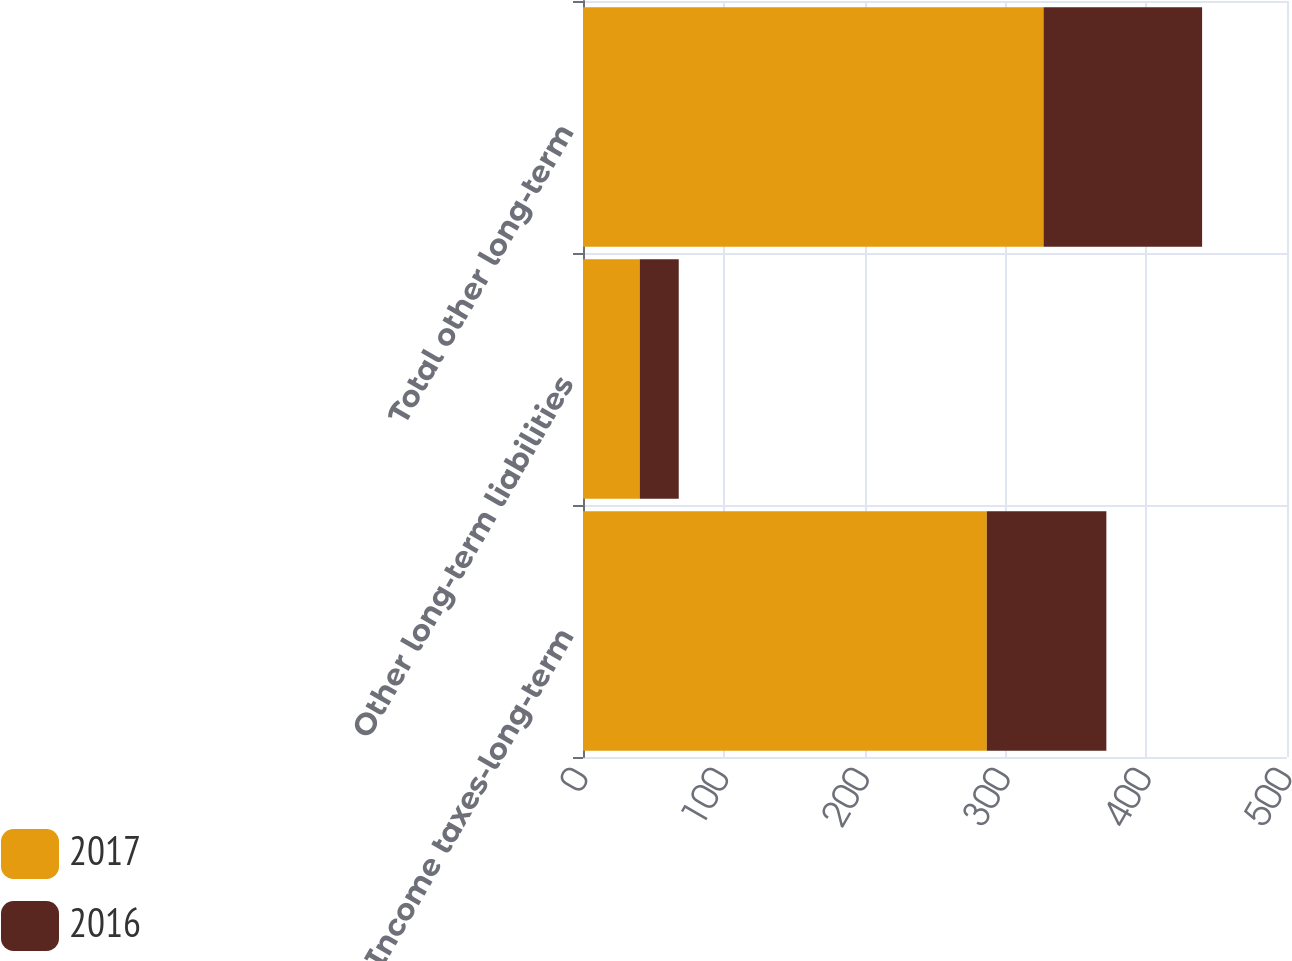<chart> <loc_0><loc_0><loc_500><loc_500><stacked_bar_chart><ecel><fcel>Income taxes-long-term<fcel>Other long-term liabilities<fcel>Total other long-term<nl><fcel>2017<fcel>286.8<fcel>40.3<fcel>327.1<nl><fcel>2016<fcel>84.9<fcel>27.7<fcel>112.6<nl></chart> 